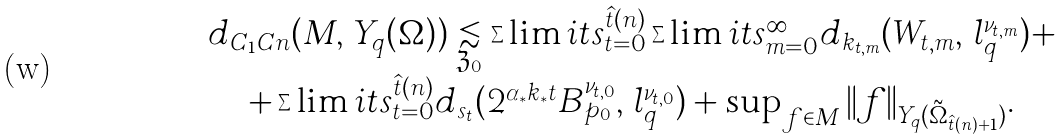<formula> <loc_0><loc_0><loc_500><loc_500>\begin{array} { c } d _ { C _ { 1 } C n } ( M , \, Y _ { q } ( \Omega ) ) \underset { \mathfrak { Z } _ { 0 } } { \lesssim } \sum \lim i t s _ { t = 0 } ^ { \hat { t } ( n ) } \sum \lim i t s _ { m = 0 } ^ { \infty } d _ { k _ { t , m } } ( W _ { t , m } , \, l _ { q } ^ { \nu _ { t , m } } ) + \\ + \sum \lim i t s _ { t = 0 } ^ { \hat { t } ( n ) } d _ { s _ { t } } ( 2 ^ { \alpha _ { * } k _ { * } t } B _ { p _ { 0 } } ^ { \nu _ { t , 0 } } , \, l _ { q } ^ { \nu _ { t , 0 } } ) + \sup _ { f \in M } \| f \| _ { Y _ { q } ( \tilde { \Omega } _ { \hat { t } ( n ) + 1 } ) } . \end{array}</formula> 